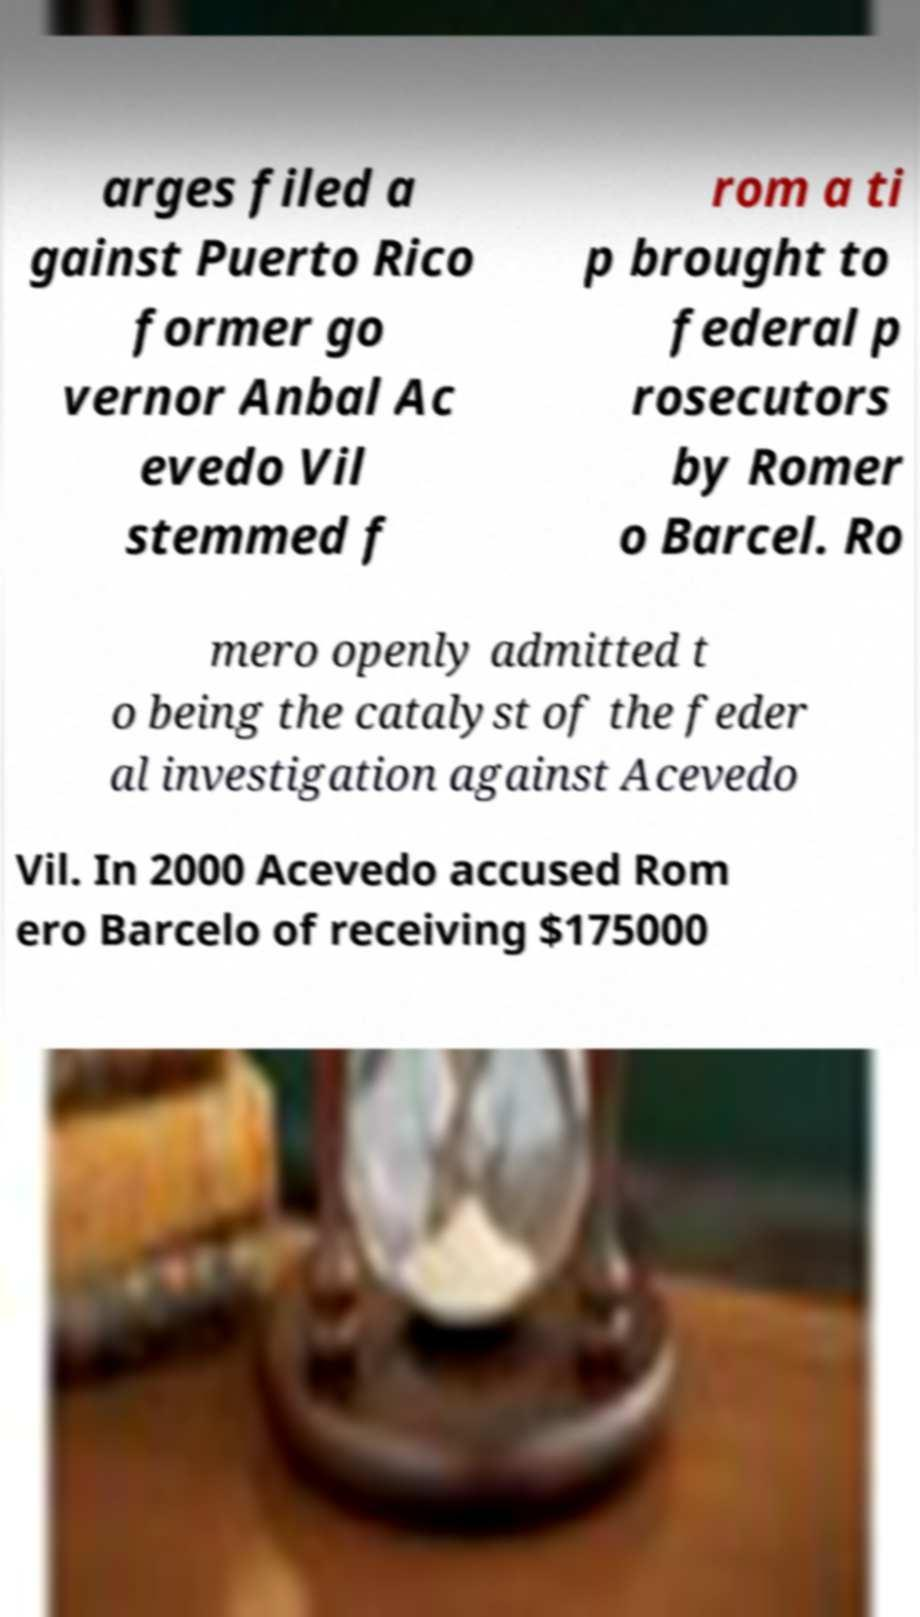What messages or text are displayed in this image? I need them in a readable, typed format. arges filed a gainst Puerto Rico former go vernor Anbal Ac evedo Vil stemmed f rom a ti p brought to federal p rosecutors by Romer o Barcel. Ro mero openly admitted t o being the catalyst of the feder al investigation against Acevedo Vil. In 2000 Acevedo accused Rom ero Barcelo of receiving $175000 